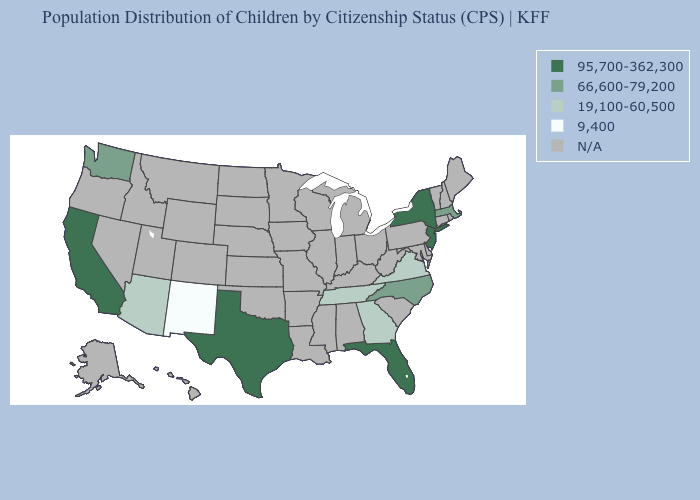Does the map have missing data?
Write a very short answer. Yes. Does the first symbol in the legend represent the smallest category?
Concise answer only. No. Does the first symbol in the legend represent the smallest category?
Be succinct. No. What is the value of Iowa?
Write a very short answer. N/A. Which states have the highest value in the USA?
Give a very brief answer. California, Florida, New Jersey, New York, Texas. What is the lowest value in the USA?
Quick response, please. 9,400. Does Georgia have the highest value in the USA?
Quick response, please. No. Among the states that border Arkansas , does Texas have the highest value?
Concise answer only. Yes. Does Massachusetts have the highest value in the Northeast?
Quick response, please. No. Is the legend a continuous bar?
Short answer required. No. What is the value of North Carolina?
Quick response, please. 66,600-79,200. What is the value of Alabama?
Keep it brief. N/A. Does the first symbol in the legend represent the smallest category?
Keep it brief. No. 